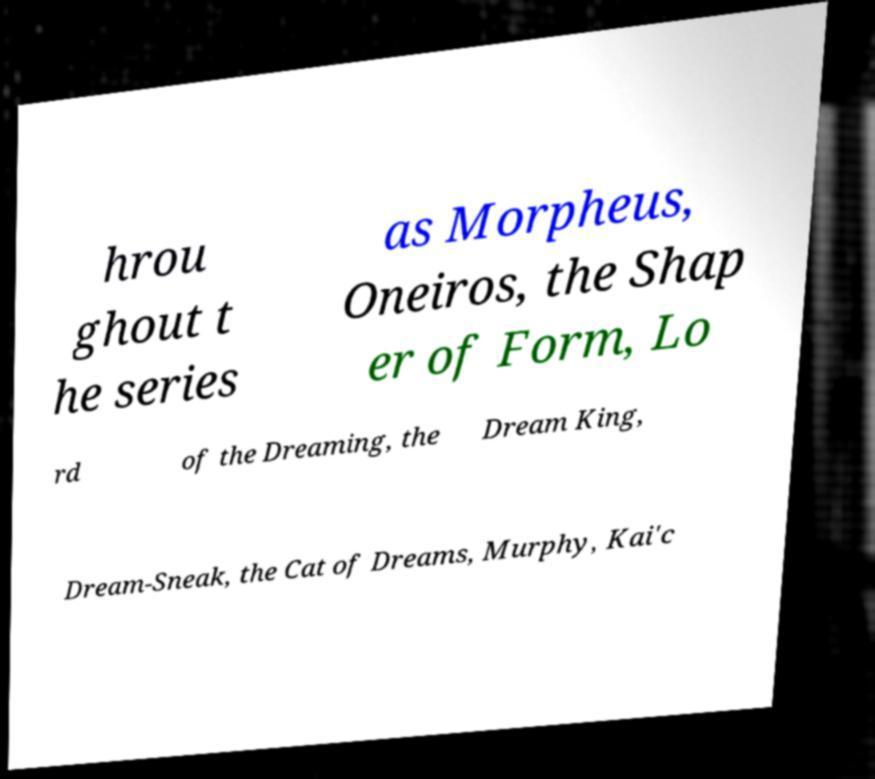Could you assist in decoding the text presented in this image and type it out clearly? hrou ghout t he series as Morpheus, Oneiros, the Shap er of Form, Lo rd of the Dreaming, the Dream King, Dream-Sneak, the Cat of Dreams, Murphy, Kai'c 